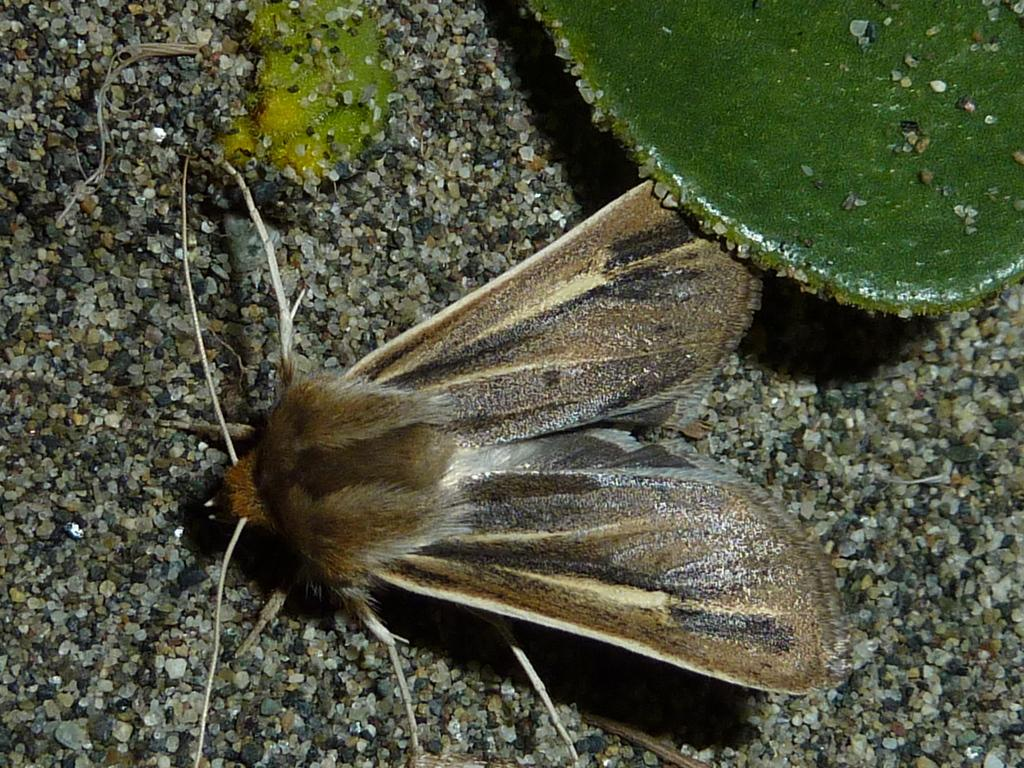What is the main subject in the center of the image? There is a moth in the center of the image. Where can a leaf be found in the image? There is a leaf in the top right corner of the image. What can be seen in the background of the image? There are stones visible in the background of the image. What type of food is the moth eating in the image? There is no food visible in the image, and the moth is not shown eating anything. 